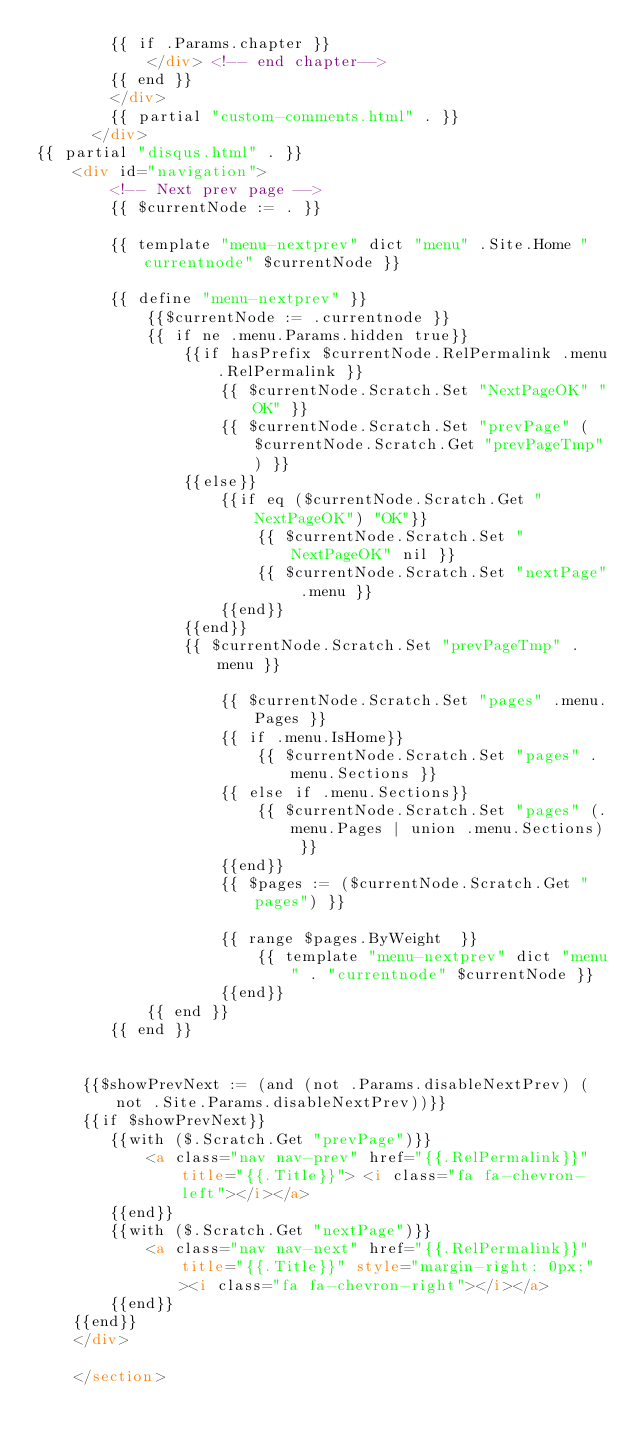Convert code to text. <code><loc_0><loc_0><loc_500><loc_500><_HTML_>        {{ if .Params.chapter }}
            </div> <!-- end chapter-->
        {{ end }}
        </div>
        {{ partial "custom-comments.html" . }}
      </div>
{{ partial "disqus.html" . }}
    <div id="navigation">
        <!-- Next prev page -->
        {{ $currentNode := . }}

        {{ template "menu-nextprev" dict "menu" .Site.Home "currentnode" $currentNode }}

        {{ define "menu-nextprev" }}
            {{$currentNode := .currentnode }}
            {{ if ne .menu.Params.hidden true}}
                {{if hasPrefix $currentNode.RelPermalink .menu.RelPermalink }}
                    {{ $currentNode.Scratch.Set "NextPageOK" "OK" }}
                    {{ $currentNode.Scratch.Set "prevPage" ($currentNode.Scratch.Get "prevPageTmp") }}
                {{else}}
                    {{if eq ($currentNode.Scratch.Get "NextPageOK") "OK"}}
                        {{ $currentNode.Scratch.Set "NextPageOK" nil }}
                        {{ $currentNode.Scratch.Set "nextPage" .menu }}
                    {{end}}
                {{end}}
                {{ $currentNode.Scratch.Set "prevPageTmp" .menu }}

                    {{ $currentNode.Scratch.Set "pages" .menu.Pages }}
                    {{ if .menu.IsHome}}
                        {{ $currentNode.Scratch.Set "pages" .menu.Sections }}
                    {{ else if .menu.Sections}}
                        {{ $currentNode.Scratch.Set "pages" (.menu.Pages | union .menu.Sections) }}
                    {{end}}
                    {{ $pages := ($currentNode.Scratch.Get "pages") }}

                    {{ range $pages.ByWeight  }}
                        {{ template "menu-nextprev" dict "menu" . "currentnode" $currentNode }}
                    {{end}}
            {{ end }}
        {{ end }}


	 {{$showPrevNext := (and (not .Params.disableNextPrev) (not .Site.Params.disableNextPrev))}}
	 {{if $showPrevNext}}
		{{with ($.Scratch.Get "prevPage")}}
			<a class="nav nav-prev" href="{{.RelPermalink}}" title="{{.Title}}"> <i class="fa fa-chevron-left"></i></a>
		{{end}}
		{{with ($.Scratch.Get "nextPage")}}
			<a class="nav nav-next" href="{{.RelPermalink}}" title="{{.Title}}" style="margin-right: 0px;"><i class="fa fa-chevron-right"></i></a>
		{{end}}
	{{end}}
    </div>

    </section>
</code> 